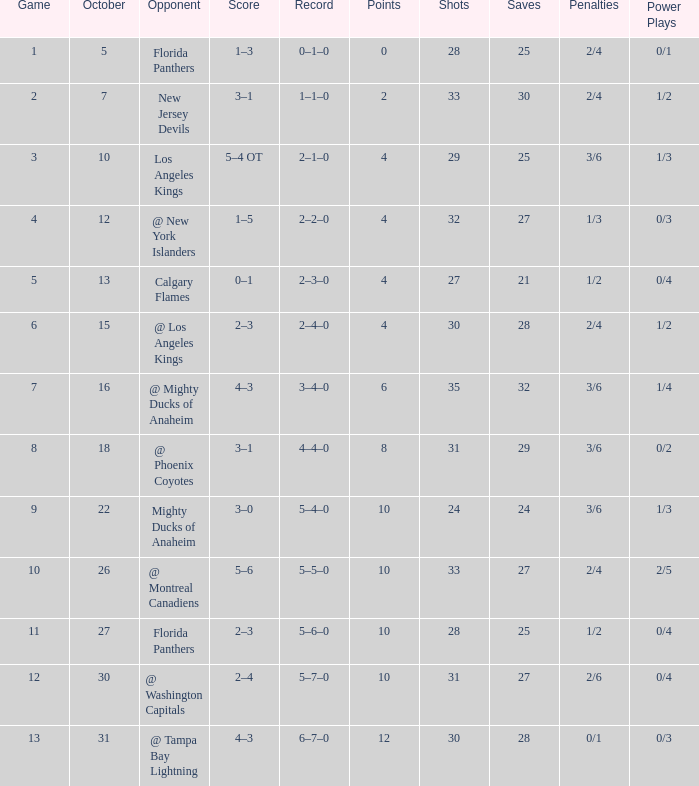What team has a score of 2 3–1. 